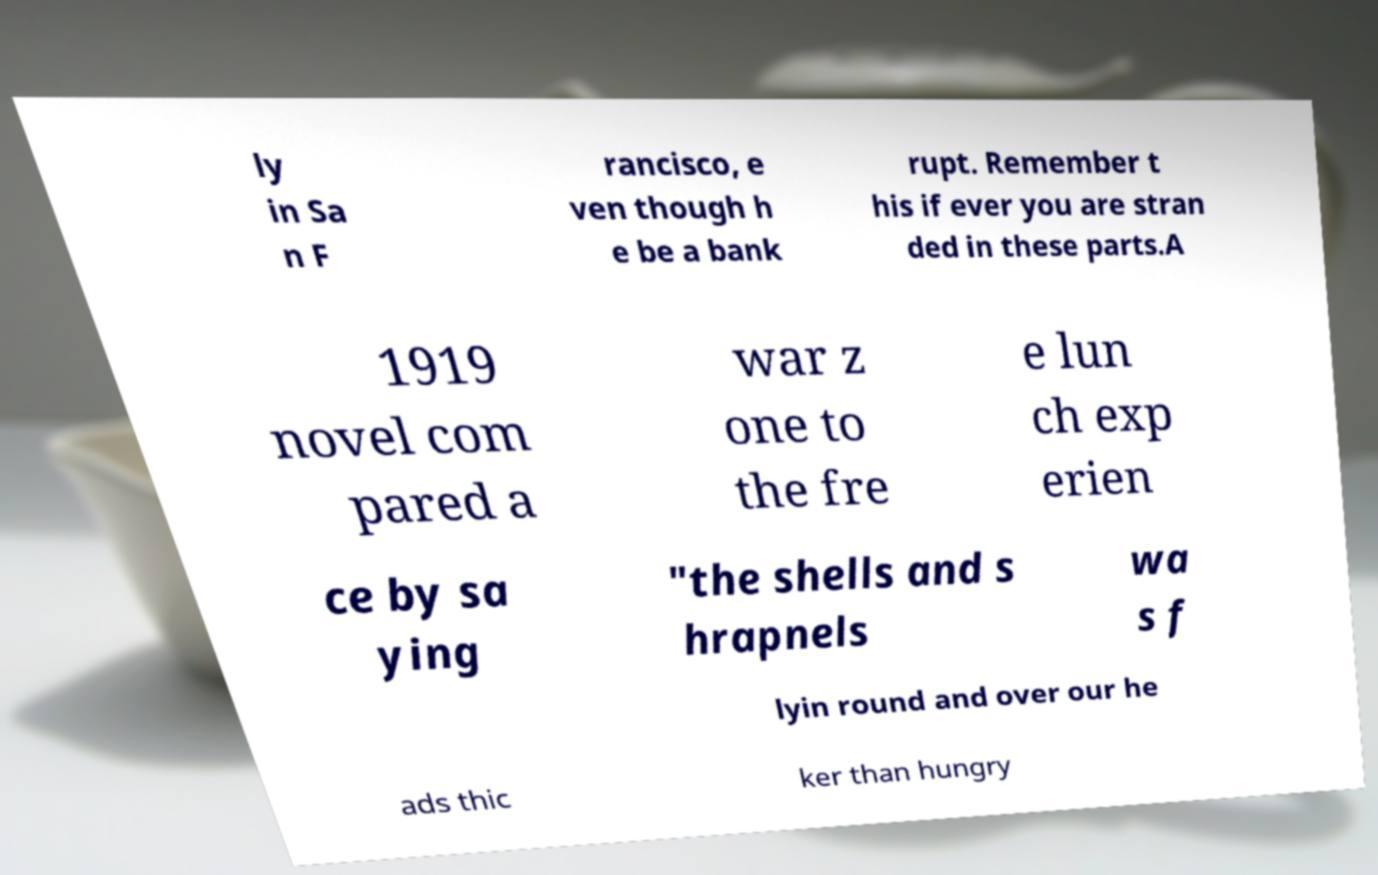I need the written content from this picture converted into text. Can you do that? ly in Sa n F rancisco, e ven though h e be a bank rupt. Remember t his if ever you are stran ded in these parts.A 1919 novel com pared a war z one to the fre e lun ch exp erien ce by sa ying "the shells and s hrapnels wa s f lyin round and over our he ads thic ker than hungry 